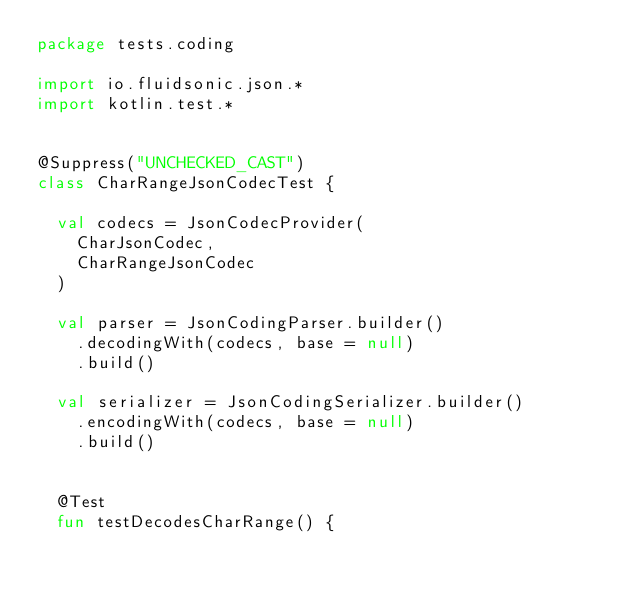<code> <loc_0><loc_0><loc_500><loc_500><_Kotlin_>package tests.coding

import io.fluidsonic.json.*
import kotlin.test.*


@Suppress("UNCHECKED_CAST")
class CharRangeJsonCodecTest {

	val codecs = JsonCodecProvider(
		CharJsonCodec,
		CharRangeJsonCodec
	)

	val parser = JsonCodingParser.builder()
		.decodingWith(codecs, base = null)
		.build()

	val serializer = JsonCodingSerializer.builder()
		.encodingWith(codecs, base = null)
		.build()


	@Test
	fun testDecodesCharRange() {</code> 